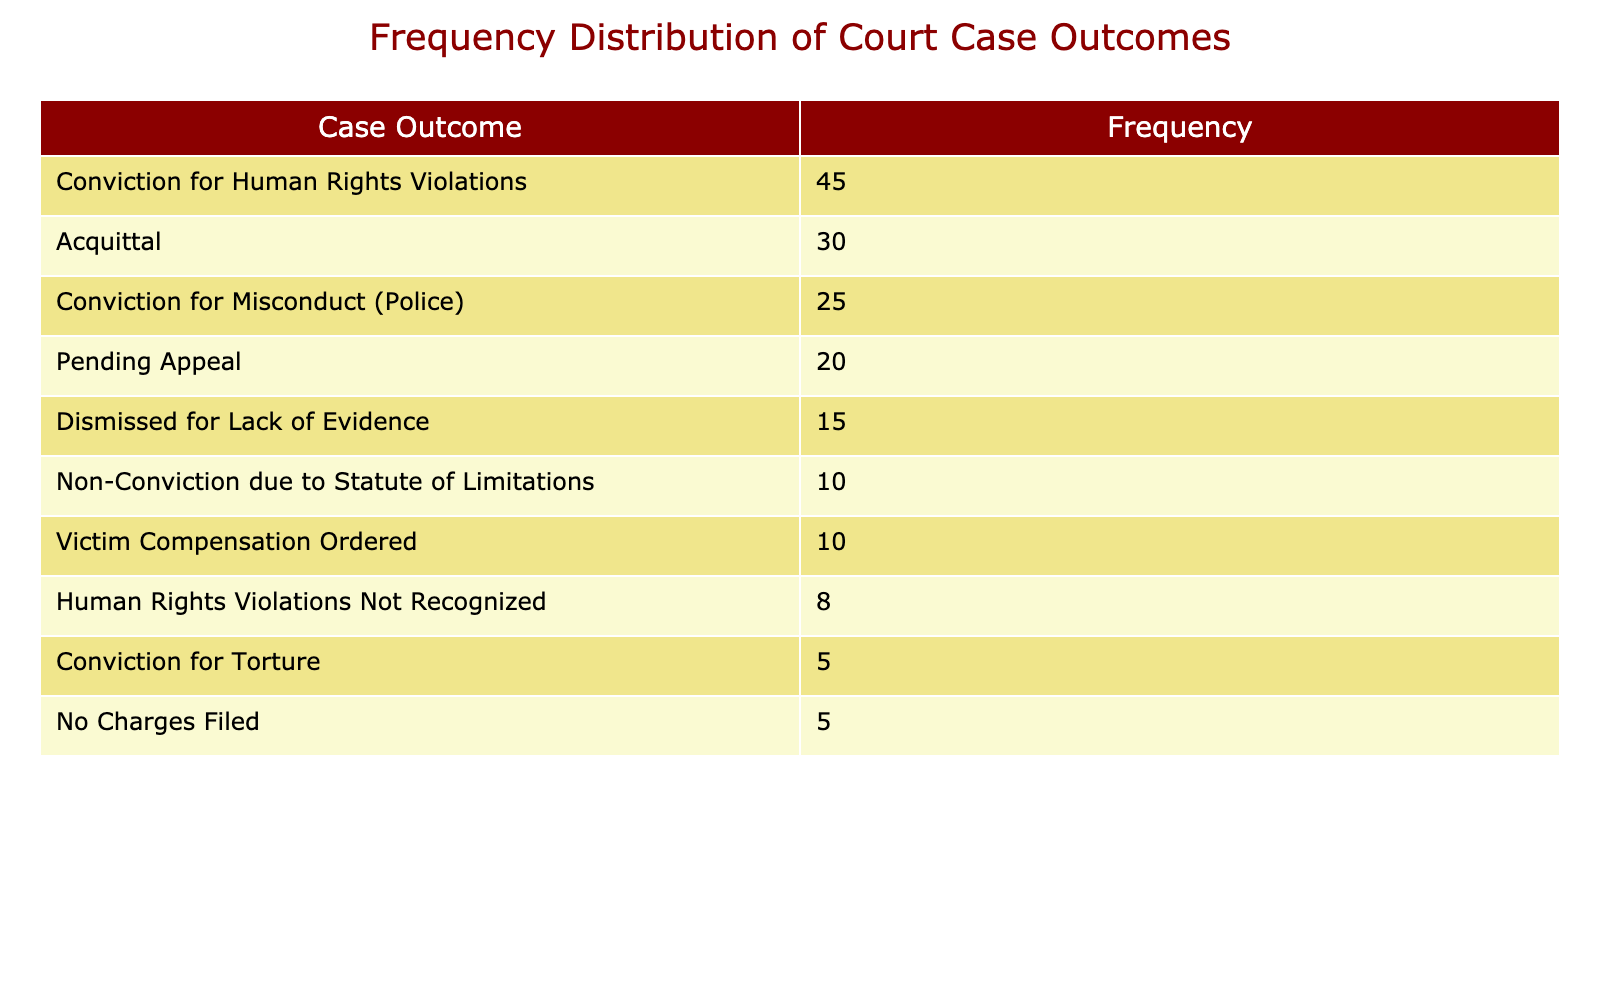What is the most common outcome for court cases related to human rights violations? The table lists the case outcomes along with their frequencies. The highest frequency value is 45, which corresponds to "Conviction for Human Rights Violations."
Answer: Conviction for Human Rights Violations How many cases resulted in an acquittal? According to the table, the frequency of acquittals is directly provided as 30.
Answer: 30 What total number of cases ended with a conviction for misconduct (police)? The table states the frequency for "Conviction for Misconduct (Police)" as 25.
Answer: 25 What is the combined total of cases that were dismissed for lack of evidence and those where no charges were filed? The frequency for "Dismissed for Lack of Evidence" is 15, and for "No Charges Filed," it is 5. Adding these two gives 15 + 5 = 20.
Answer: 20 Is it true that there were more cases leading to a conviction for torture than cases where victim compensation was ordered? The frequency for "Conviction for Torture" is 5, and for "Victim Compensation Ordered," it is 10. Since 5 is less than 10, the statement is false.
Answer: No What is the frequency of cases where human rights violations were not recognized? The table lists the frequency of "Human Rights Violations Not Recognized" as 8.
Answer: 8 If you consider the outcomes categorized under conviction, how many cases resulted in a conviction overall? The table lists "Conviction for Human Rights Violations" as 45, "Conviction for Misconduct (Police)" as 25, and "Conviction for Torture" as 5. Adding these together gives 45 + 25 + 5 = 75.
Answer: 75 Has the number of cases pending appeal exceeded the number of cases that resulted in a dismissal for lack of evidence? The frequency for "Pending Appeal" is 20, and for "Dismissed for Lack of Evidence," it is 15. Since 20 is greater than 15, the statement is true.
Answer: Yes What percentage of the total case outcomes resulted in conviction for human rights violations? The total frequency of cases is 45 + 30 + 20 + 15 + 25 + 10 + 5 + 10 + 5 + 8 =  173. The frequency of "Conviction for Human Rights Violations" is 45. To find the percentage, (45 / 173) * 100 ≈ 26%.
Answer: Approximately 26% 